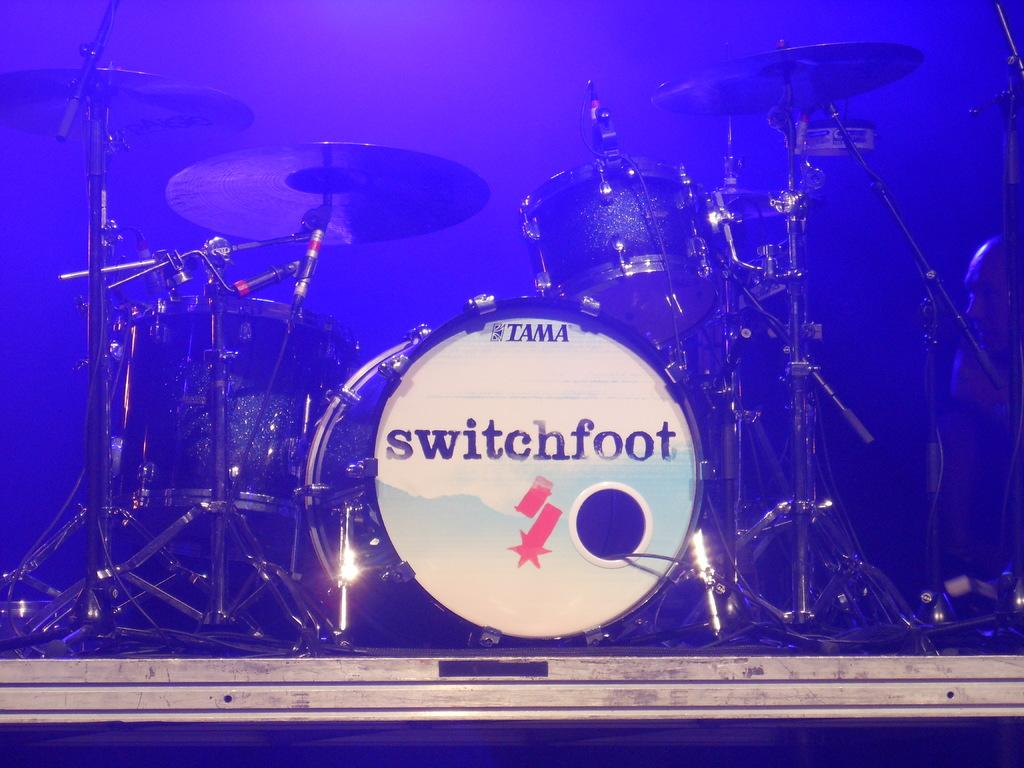What musical instruments are present in the image? There are drums in the image. Where are the drums located? The drums are on a stage. Can you see a fight happening between the drums and the stage in the image? No, there is no fight happening between the drums and the stage in the image. 